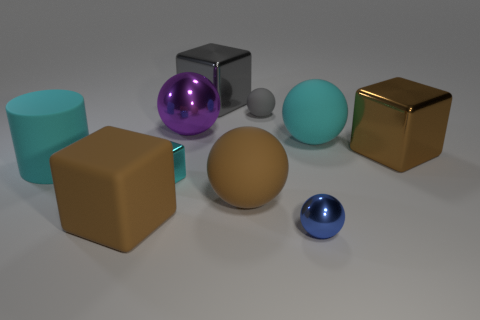The small sphere that is made of the same material as the tiny cyan cube is what color?
Your answer should be very brief. Blue. Is the number of cyan cylinders greater than the number of yellow rubber objects?
Offer a very short reply. Yes. Is there a purple ball?
Give a very brief answer. Yes. What shape is the cyan object that is behind the cyan matte object that is left of the purple metal ball?
Provide a short and direct response. Sphere. How many things are either big cyan rubber cylinders or metallic blocks right of the tiny blue ball?
Your answer should be very brief. 2. What is the color of the sphere that is in front of the brown block that is to the left of the big rubber ball that is right of the tiny blue metal object?
Offer a very short reply. Blue. There is a cyan object that is the same shape as the blue thing; what is it made of?
Make the answer very short. Rubber. The tiny matte sphere is what color?
Provide a short and direct response. Gray. Is the color of the rubber cylinder the same as the tiny metallic block?
Give a very brief answer. Yes. What number of rubber things are gray blocks or cylinders?
Your answer should be very brief. 1. 